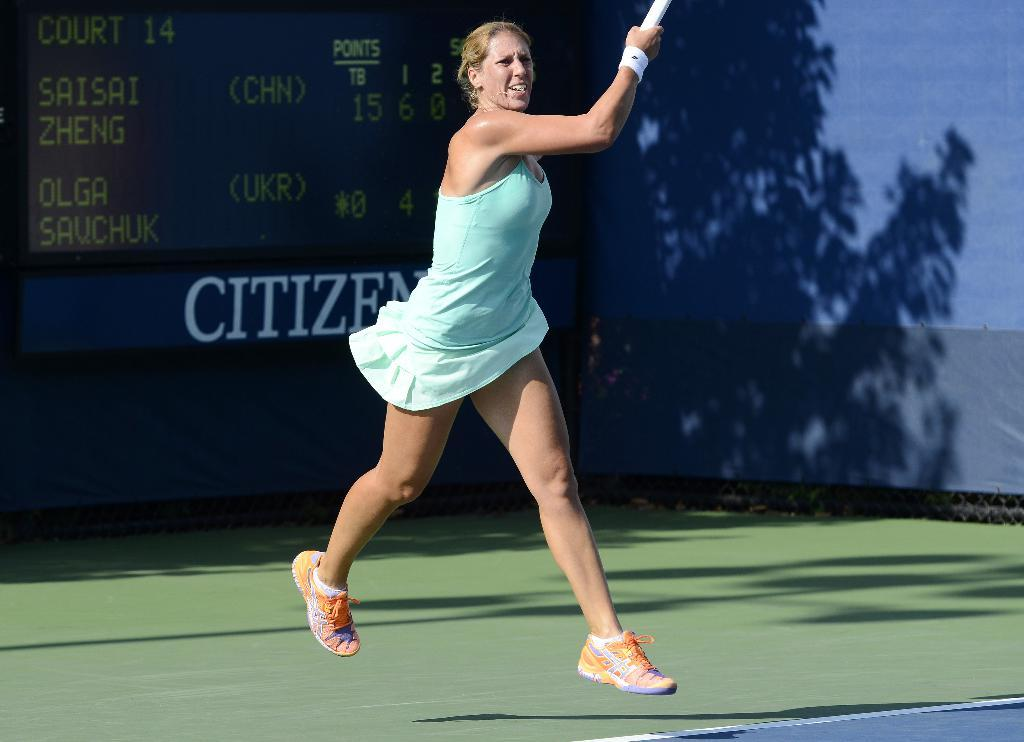What is the person in the image doing? The person is playing a game. What can be seen in the background of the image? There are trees and a name board in the background of the image. What type of disgust can be seen on the person's face while playing the game? There is no indication of disgust on the person's face in the image. How many pies are visible on the person's shirt in the image? There are no pies or shirts visible in the image. 